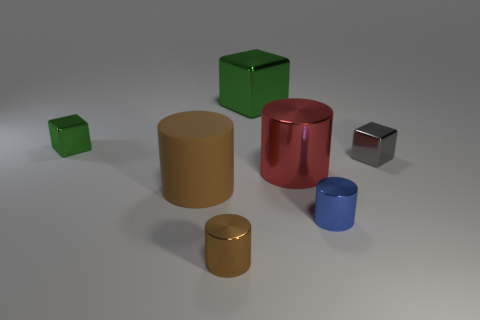There is a large object that is behind the small green object; is it the same color as the small metallic cube to the left of the tiny brown metal object?
Keep it short and to the point. Yes. The thing that is both in front of the small gray block and left of the tiny brown object is made of what material?
Make the answer very short. Rubber. The large metallic block is what color?
Offer a very short reply. Green. What number of other things are there of the same shape as the blue metal object?
Give a very brief answer. 3. Is the number of blue cylinders left of the rubber cylinder the same as the number of metallic cubes that are behind the tiny green cube?
Give a very brief answer. No. What is the big brown cylinder made of?
Your answer should be very brief. Rubber. There is a large cylinder left of the large red metallic cylinder; what is its material?
Provide a short and direct response. Rubber. Is there any other thing that has the same material as the big brown thing?
Give a very brief answer. No. Is the number of tiny objects that are right of the tiny brown cylinder greater than the number of red cylinders?
Provide a short and direct response. Yes. Are there any red metal objects on the left side of the tiny brown metallic thing to the left of the green shiny object that is on the right side of the small green thing?
Offer a very short reply. No. 